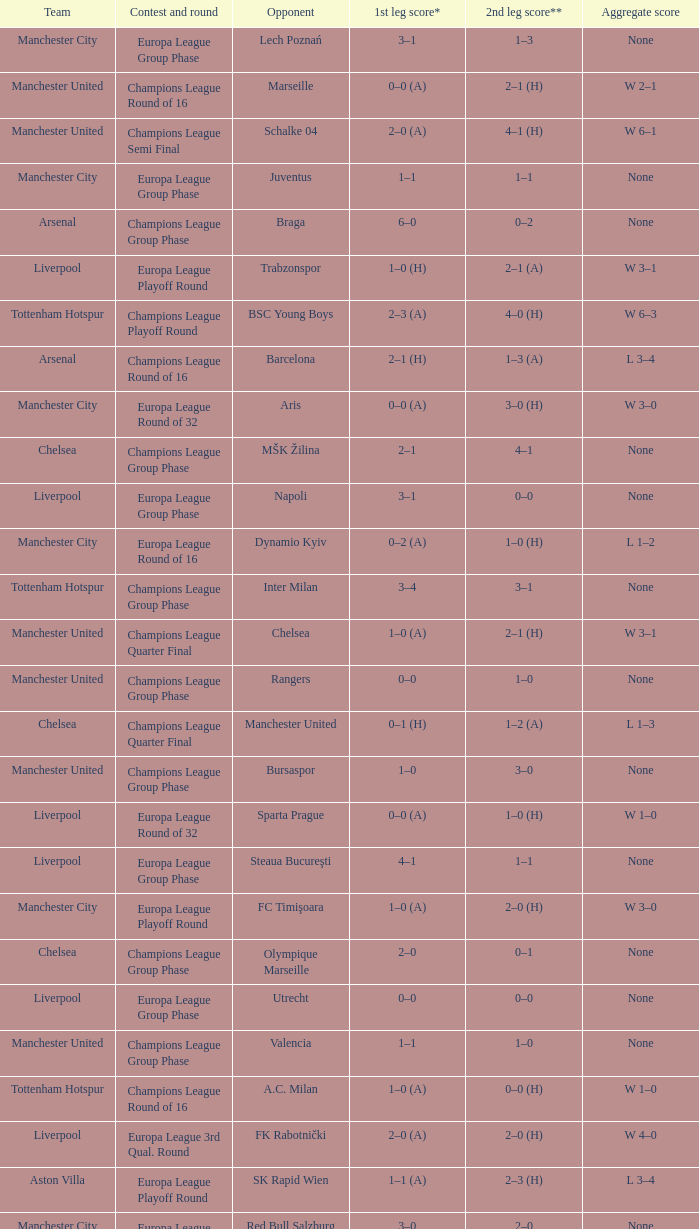How many goals did each one of the teams score in the first leg of the match between Liverpool and Trabzonspor? 1–0 (H). 